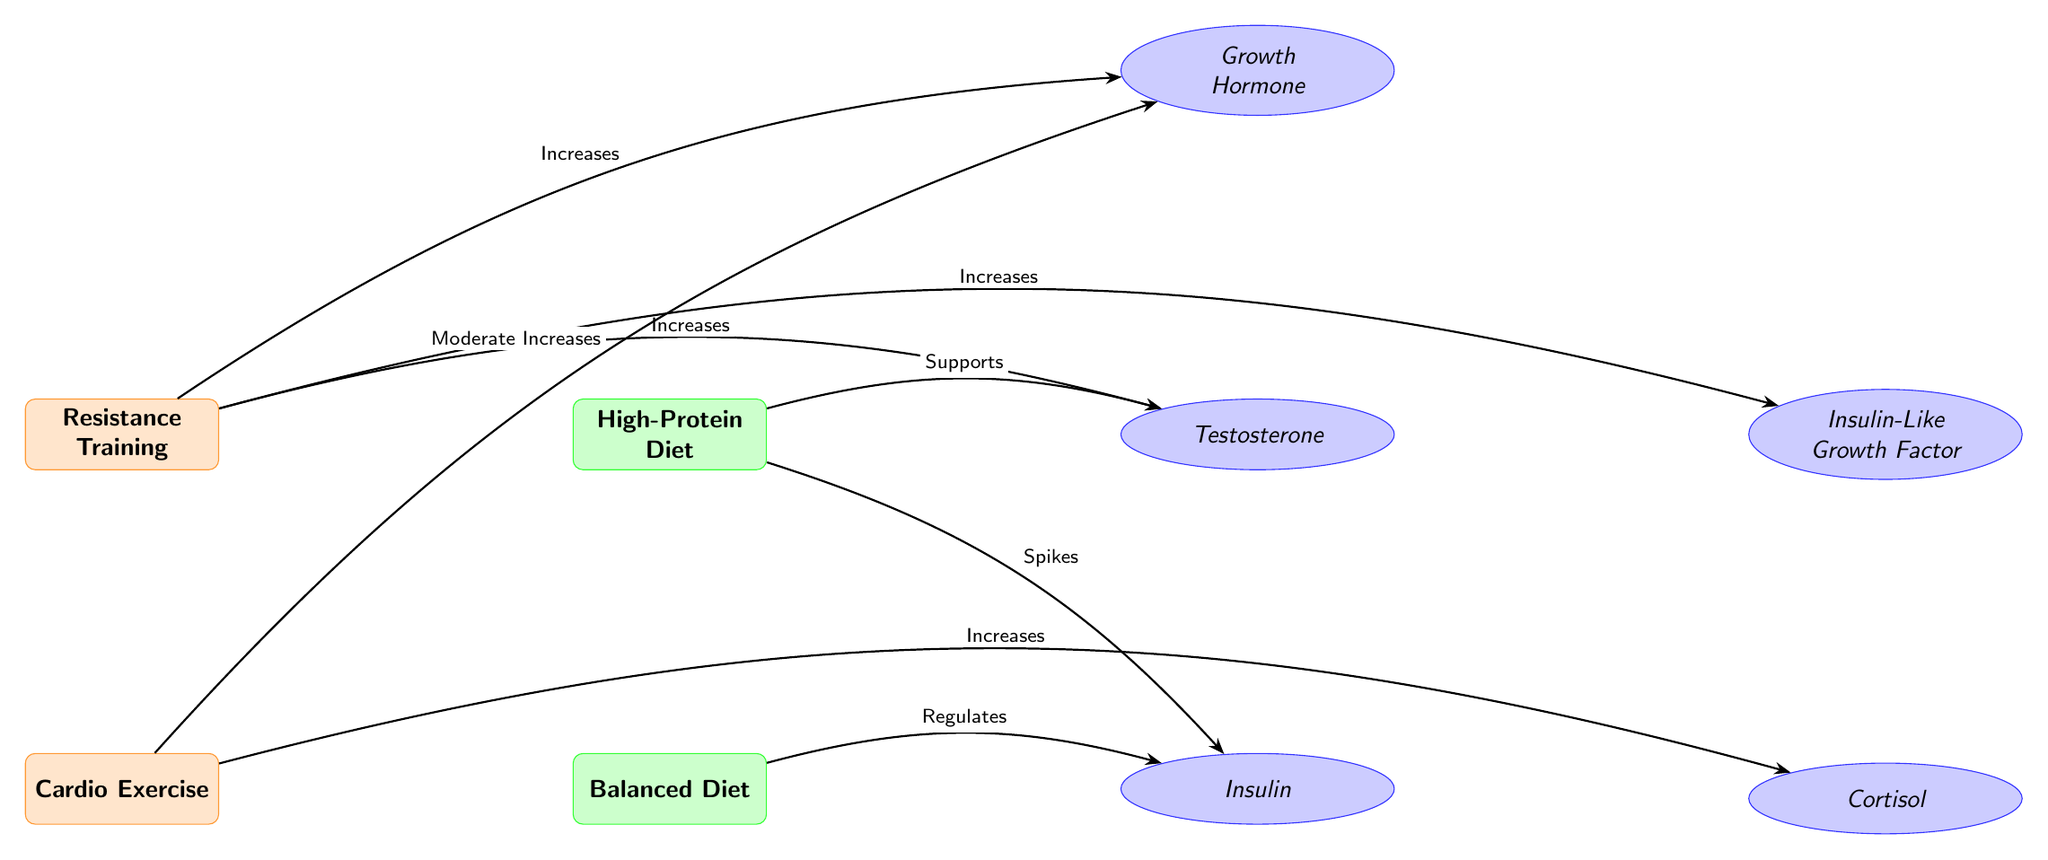What type of exercise increases testosterone? The diagram shows an arrow labeled "Increases" going from the "Resistance Training" node to the "Testosterone" hormone node.
Answer: Resistance Training How many diet nodes are present in the diagram? There are two diet nodes: "High-Protein Diet" and "Balanced Diet." Counting them gives a total of 2.
Answer: 2 What hormone is regulated by a balanced diet? The diagram indicates with an arrow that the "Balanced Diet" node "Regulates" the "Insulin" hormone node.
Answer: Insulin Which hormone is supported by a high-protein diet? The diagram has an arrow from the "High-Protein Diet" node to the "Testosterone" hormone, labeled "Supports."
Answer: Testosterone What is the relationship between cardio exercise and growth hormone? There is an arrow from the "Cardio Exercise" node to the "Growth Hormone" node, labeled "Moderate Increases," indicating a positive but moderate effect.
Answer: Moderate Increases What effect does resistance training have on IGF? The diagram shows an arrow leading from the "Resistance Training" node to the "Insulin-Like Growth Factor" node with a label "Increases," highlighting a direct positive effect.
Answer: Increases Which hormone experiences a spike in response to a high-protein diet? The diagram specifies that the "High-Protein Diet" node causes "Spikes" in the "Insulin" hormone node, defined by the arrow connecting them.
Answer: Insulin In total, how many arrows are used in the diagram? There are six arrows connecting various nodes, representing different relationships. Counting each arrow gives a total of 6.
Answer: 6 What exercise type is associated with increased cortisol levels? The diagram indicates an arrow from the "Cardio Exercise" node to the "Cortisol" hormone node, denoting an increase in cortisol levels as a result of cardio.
Answer: Cardio Exercise 